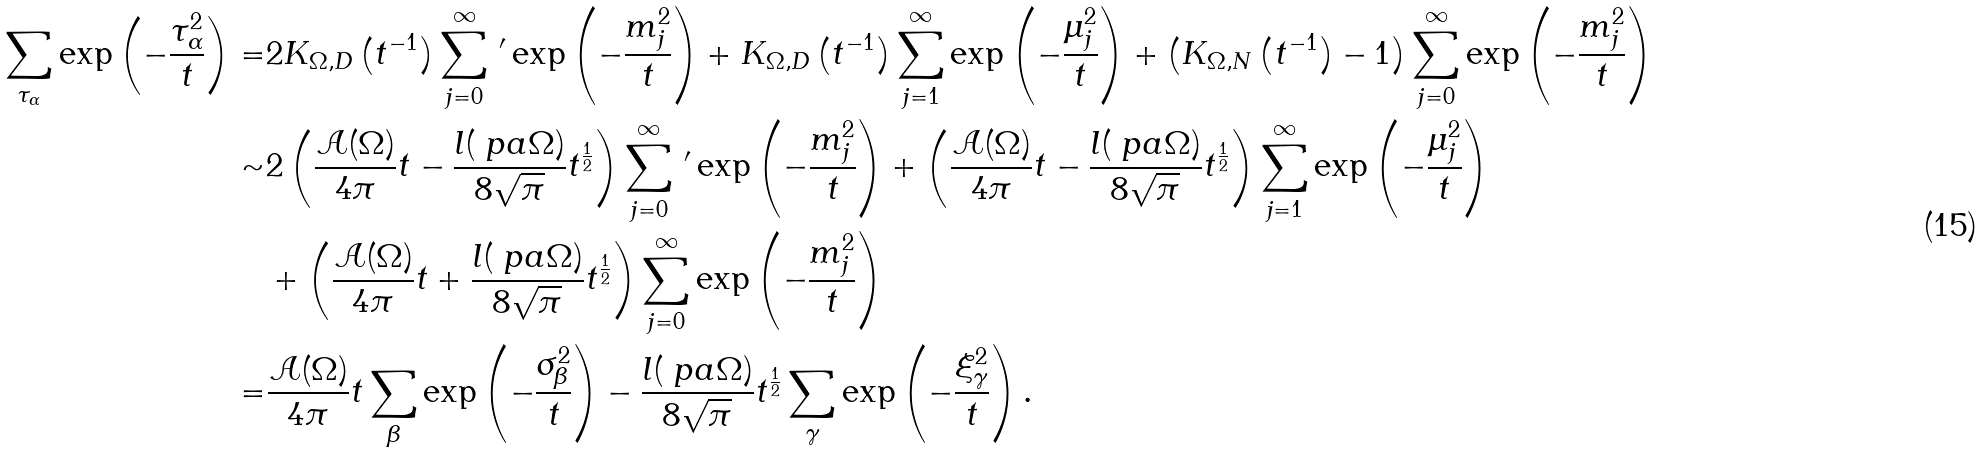Convert formula to latex. <formula><loc_0><loc_0><loc_500><loc_500>\sum _ { \tau _ { \alpha } } \exp \left ( - \frac { \tau _ { \alpha } ^ { 2 } } { t } \right ) = & 2 K _ { \Omega , D } \left ( t ^ { - 1 } \right ) \sum _ { j = 0 } ^ { \infty } \, ^ { \prime } \exp \left ( - \frac { m _ { j } ^ { 2 } } { t } \right ) + K _ { \Omega , D } \left ( t ^ { - 1 } \right ) \sum _ { j = 1 } ^ { \infty } \exp \left ( - \frac { \mu _ { j } ^ { 2 } } { t } \right ) + \left ( K _ { \Omega , N } \left ( t ^ { - 1 } \right ) - 1 \right ) \sum _ { j = 0 } ^ { \infty } \exp \left ( - \frac { m _ { j } ^ { 2 } } { t } \right ) \\ \sim & 2 \left ( \frac { \mathcal { A } ( \Omega ) } { 4 \pi } t - \frac { l ( \ p a \Omega ) } { 8 \sqrt { \pi } } t ^ { \frac { 1 } { 2 } } \right ) \sum _ { j = 0 } ^ { \infty } \, ^ { \prime } \exp \left ( - \frac { m _ { j } ^ { 2 } } { t } \right ) + \left ( \frac { \mathcal { A } ( \Omega ) } { 4 \pi } t - \frac { l ( \ p a \Omega ) } { 8 \sqrt { \pi } } t ^ { \frac { 1 } { 2 } } \right ) \sum _ { j = 1 } ^ { \infty } \exp \left ( - \frac { \mu _ { j } ^ { 2 } } { t } \right ) \\ & + \left ( \frac { \mathcal { A } ( \Omega ) } { 4 \pi } t + \frac { l ( \ p a \Omega ) } { 8 \sqrt { \pi } } t ^ { \frac { 1 } { 2 } } \right ) \sum _ { j = 0 } ^ { \infty } \exp \left ( - \frac { m _ { j } ^ { 2 } } { t } \right ) \\ = & \frac { \mathcal { A } ( \Omega ) } { 4 \pi } t \sum _ { \beta } \exp \left ( - \frac { \sigma _ { \beta } ^ { 2 } } { t } \right ) - \frac { l ( \ p a \Omega ) } { 8 \sqrt { \pi } } t ^ { \frac { 1 } { 2 } } \sum _ { \gamma } \exp \left ( - \frac { \xi _ { \gamma } ^ { 2 } } { t } \right ) .</formula> 